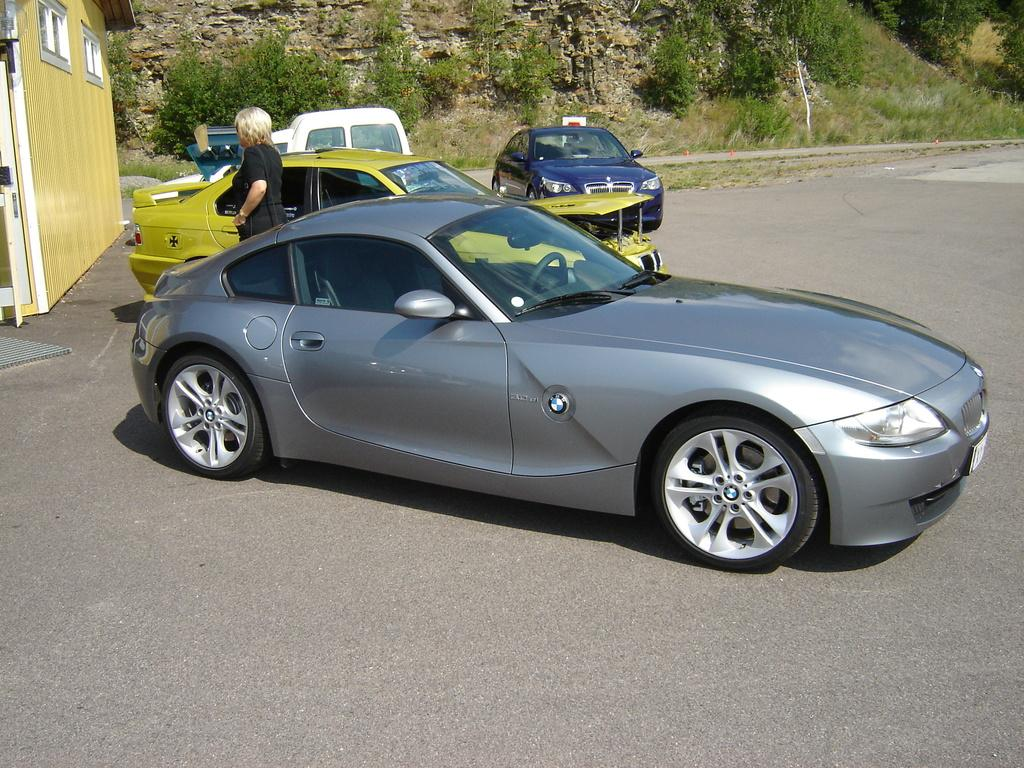What can be seen on the road in the image? There are cars parked on the road in the image. What is the woman near the car doing? There is a woman standing near a car in the image. What can be seen in the distance in the image? There are trees and a building visible in the background of the image. What type of cracker is the woman holding in the image? There is no cracker present in the image; the woman is standing near a car. What mathematical calculations is the calculator performing in the image? There is no calculator present in the image; the focus is on the parked cars and the woman standing near one of them. 